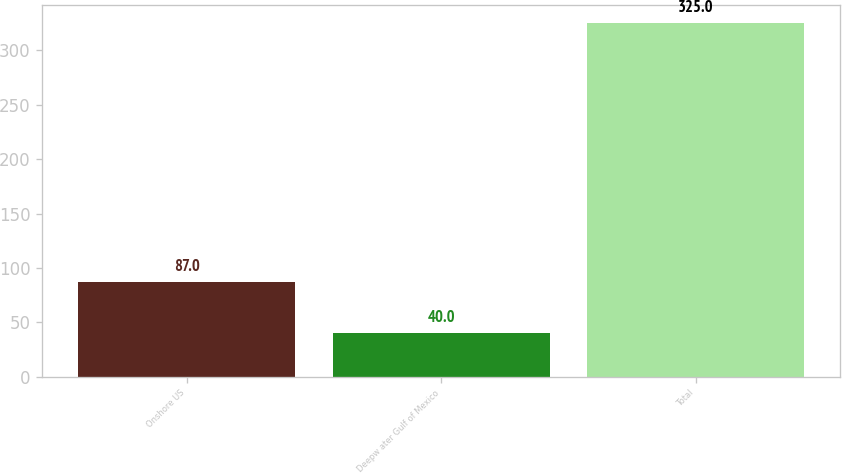<chart> <loc_0><loc_0><loc_500><loc_500><bar_chart><fcel>Onshore US<fcel>Deepw ater Gulf of Mexico<fcel>Total<nl><fcel>87<fcel>40<fcel>325<nl></chart> 